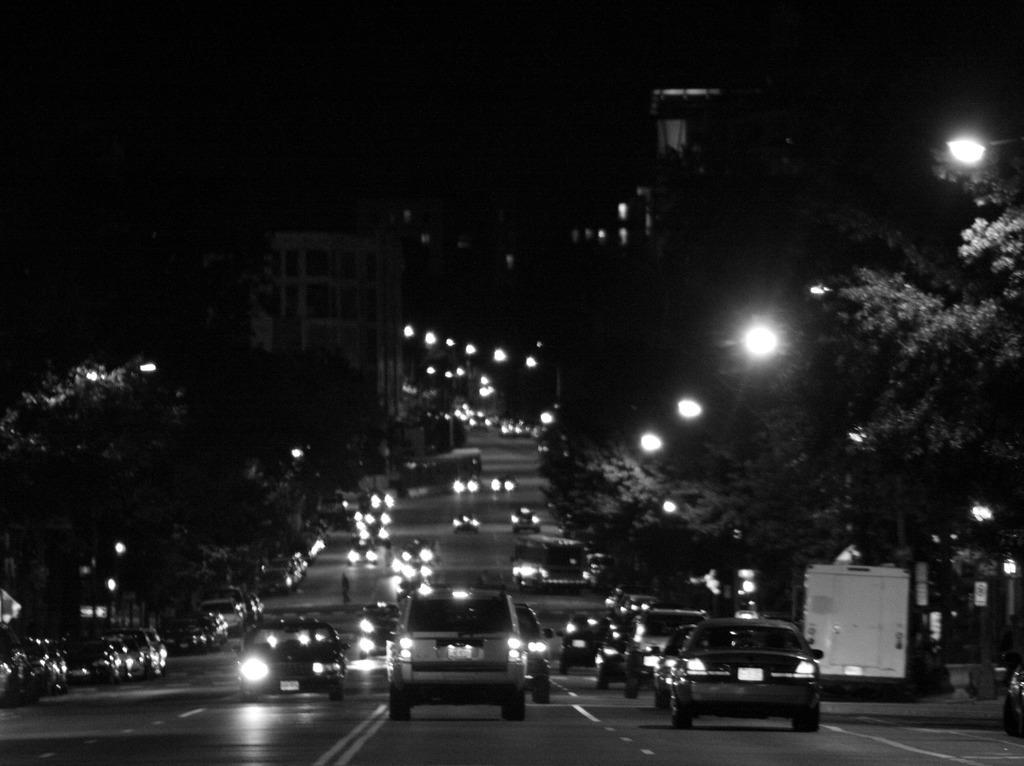In one or two sentences, can you explain what this image depicts? This is a black and white picture. At the bottom, we see the road. We see the vehicles moving on the road. On the right side, we see the trees and the street lights. On the left side, we see the trees, street lights and the vehicles parked on the road. There are trees, buildings and street lights in the background. In the background, it is black in color. This picture might be clicked in the dark. 